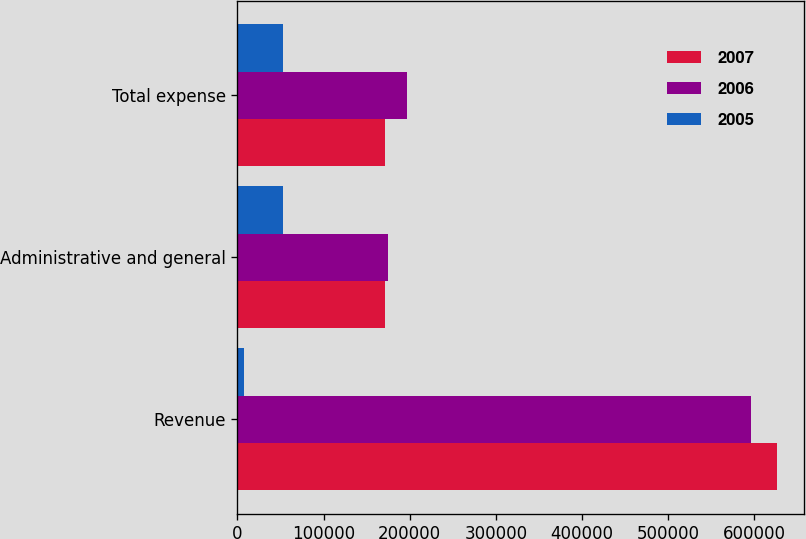Convert chart. <chart><loc_0><loc_0><loc_500><loc_500><stacked_bar_chart><ecel><fcel>Revenue<fcel>Administrative and general<fcel>Total expense<nl><fcel>2007<fcel>626764<fcel>171741<fcel>171741<nl><fcel>2006<fcel>595702<fcel>175270<fcel>196642<nl><fcel>2005<fcel>7683<fcel>52579<fcel>52579<nl></chart> 